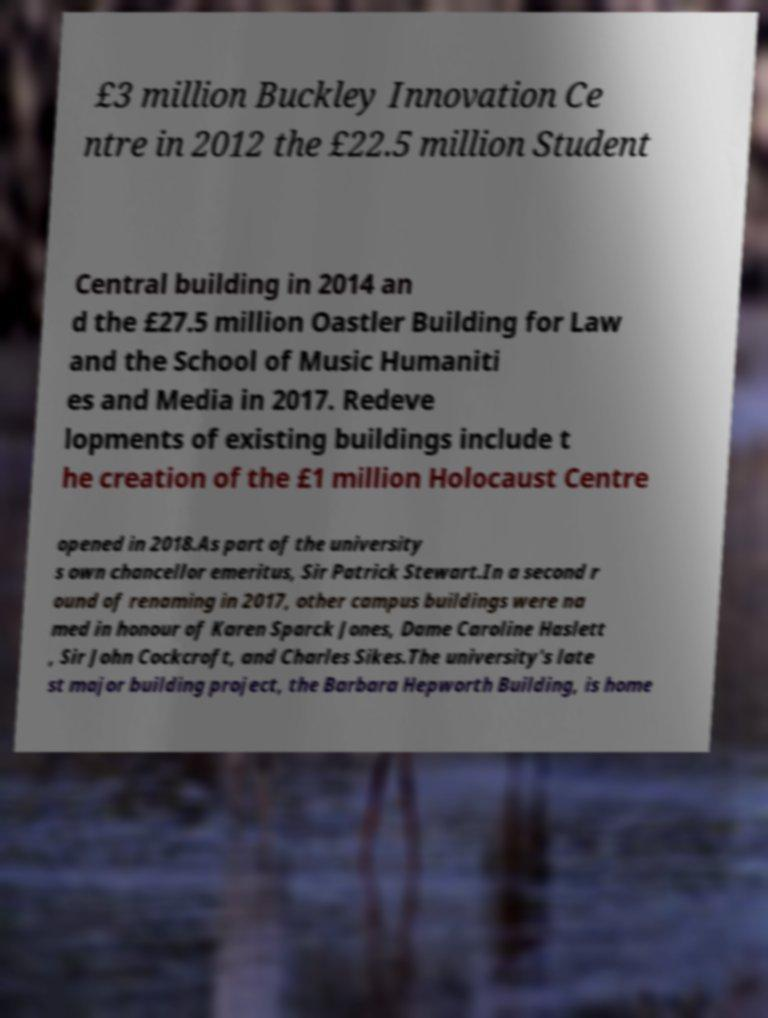What messages or text are displayed in this image? I need them in a readable, typed format. £3 million Buckley Innovation Ce ntre in 2012 the £22.5 million Student Central building in 2014 an d the £27.5 million Oastler Building for Law and the School of Music Humaniti es and Media in 2017. Redeve lopments of existing buildings include t he creation of the £1 million Holocaust Centre opened in 2018.As part of the university s own chancellor emeritus, Sir Patrick Stewart.In a second r ound of renaming in 2017, other campus buildings were na med in honour of Karen Sparck Jones, Dame Caroline Haslett , Sir John Cockcroft, and Charles Sikes.The university's late st major building project, the Barbara Hepworth Building, is home 